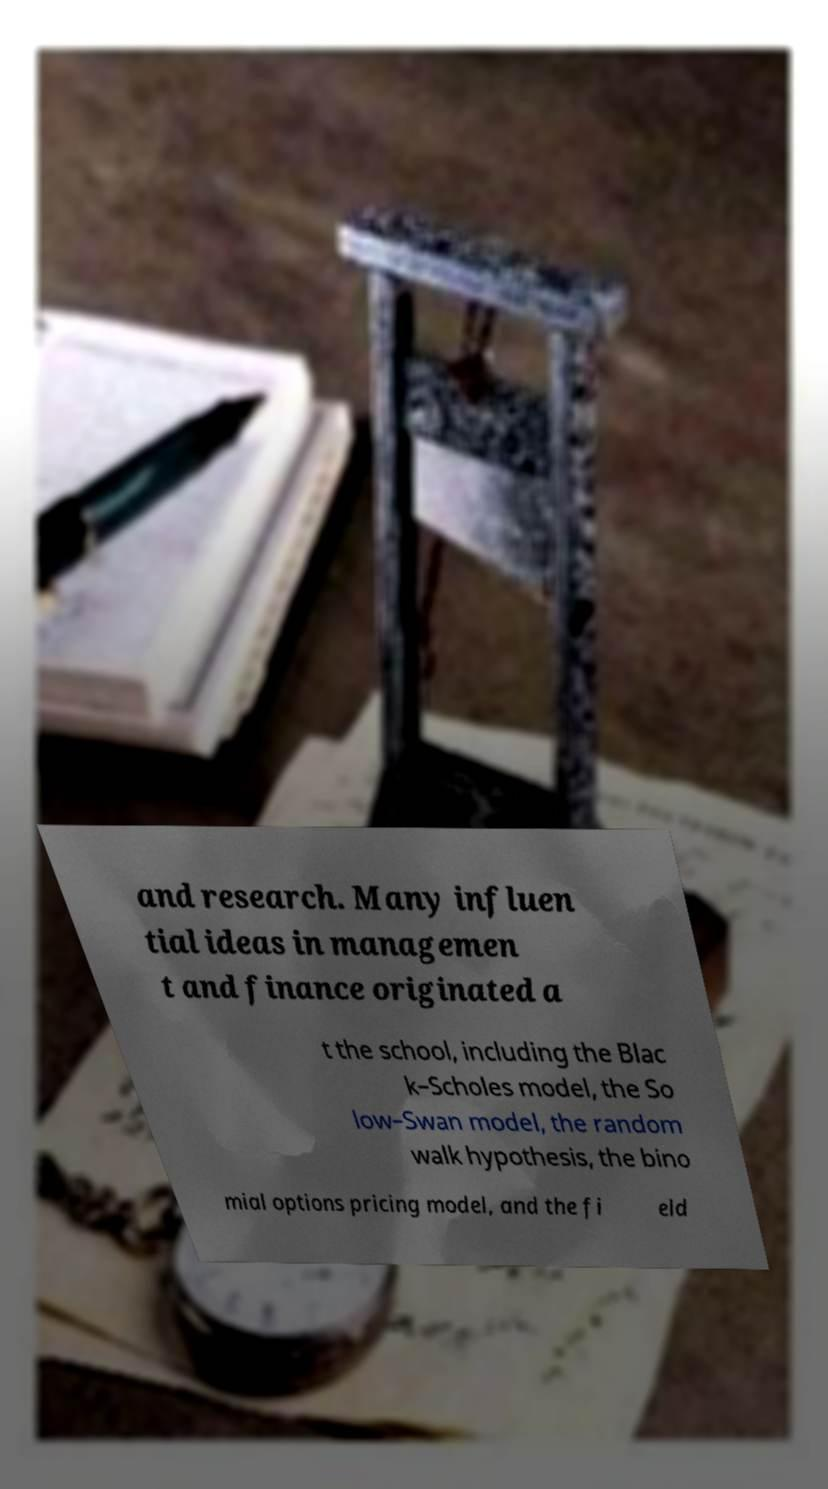There's text embedded in this image that I need extracted. Can you transcribe it verbatim? and research. Many influen tial ideas in managemen t and finance originated a t the school, including the Blac k–Scholes model, the So low–Swan model, the random walk hypothesis, the bino mial options pricing model, and the fi eld 